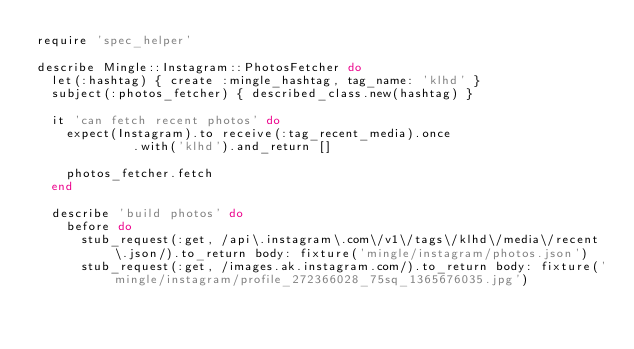<code> <loc_0><loc_0><loc_500><loc_500><_Ruby_>require 'spec_helper'

describe Mingle::Instagram::PhotosFetcher do
  let(:hashtag) { create :mingle_hashtag, tag_name: 'klhd' }
  subject(:photos_fetcher) { described_class.new(hashtag) }

  it 'can fetch recent photos' do
    expect(Instagram).to receive(:tag_recent_media).once
             .with('klhd').and_return []

    photos_fetcher.fetch
  end

  describe 'build photos' do
    before do
      stub_request(:get, /api\.instagram\.com\/v1\/tags\/klhd\/media\/recent\.json/).to_return body: fixture('mingle/instagram/photos.json')
      stub_request(:get, /images.ak.instagram.com/).to_return body: fixture('mingle/instagram/profile_272366028_75sq_1365676035.jpg')</code> 